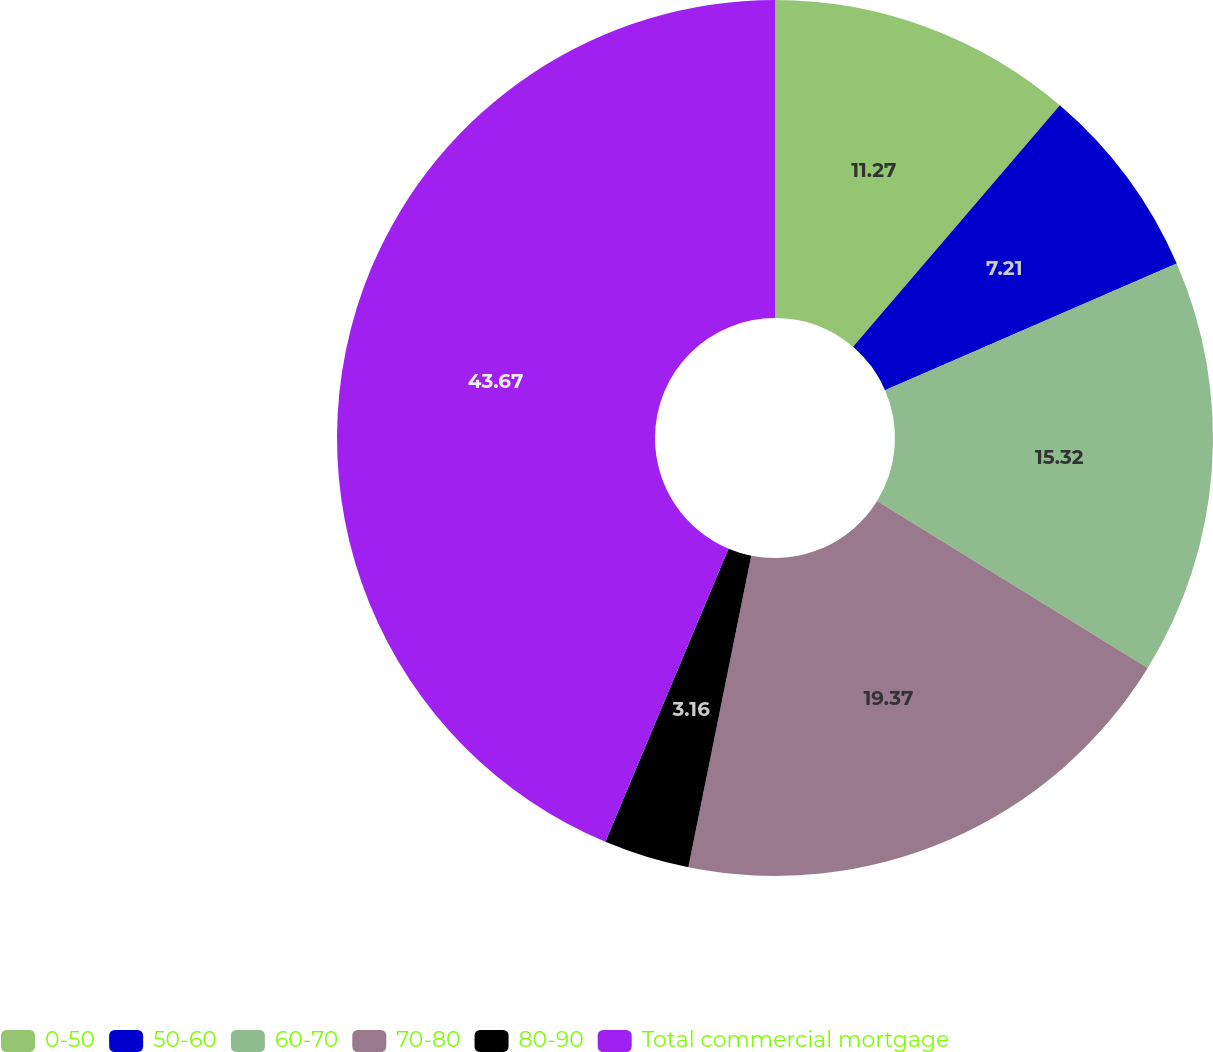<chart> <loc_0><loc_0><loc_500><loc_500><pie_chart><fcel>0-50<fcel>50-60<fcel>60-70<fcel>70-80<fcel>80-90<fcel>Total commercial mortgage<nl><fcel>11.27%<fcel>7.21%<fcel>15.32%<fcel>19.37%<fcel>3.16%<fcel>43.67%<nl></chart> 